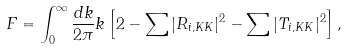<formula> <loc_0><loc_0><loc_500><loc_500>F = \int _ { 0 } ^ { \infty } \frac { d k } { 2 \pi } k \left [ 2 - \sum | R _ { i , K K } | ^ { 2 } - \sum | T _ { i , K K } | ^ { 2 } \right ] ,</formula> 